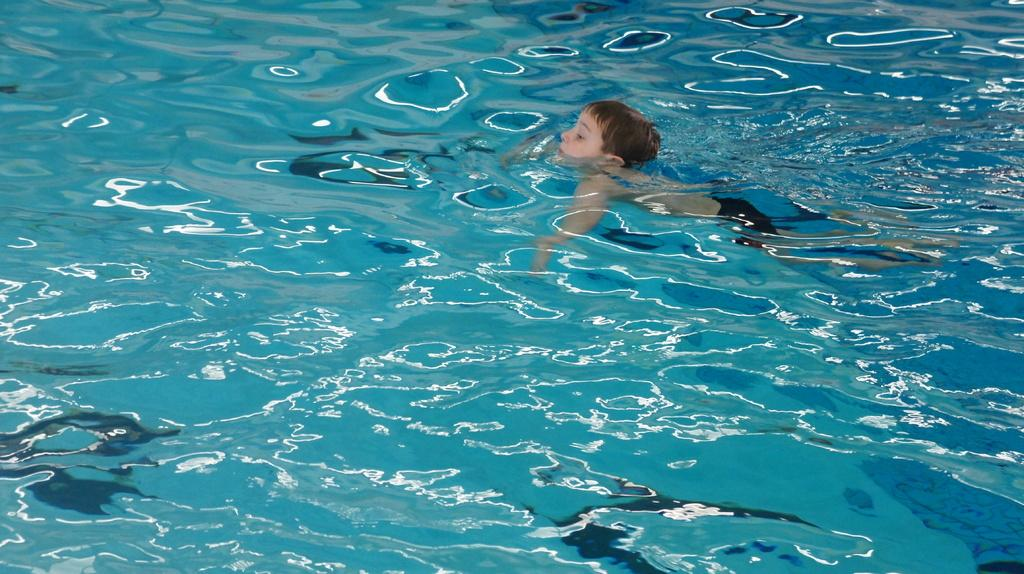What is the main subject of the image? The main subject of the image is a boy. Where is the boy located in the image? The boy is in the water in the image. What type of crime is being committed by the boy in the image? There is no indication of any crime being committed in the image; it simply shows a boy in the water. What flavor of jelly is the boy holding in the image? There is no jelly present in the image; the boy is in the water. 